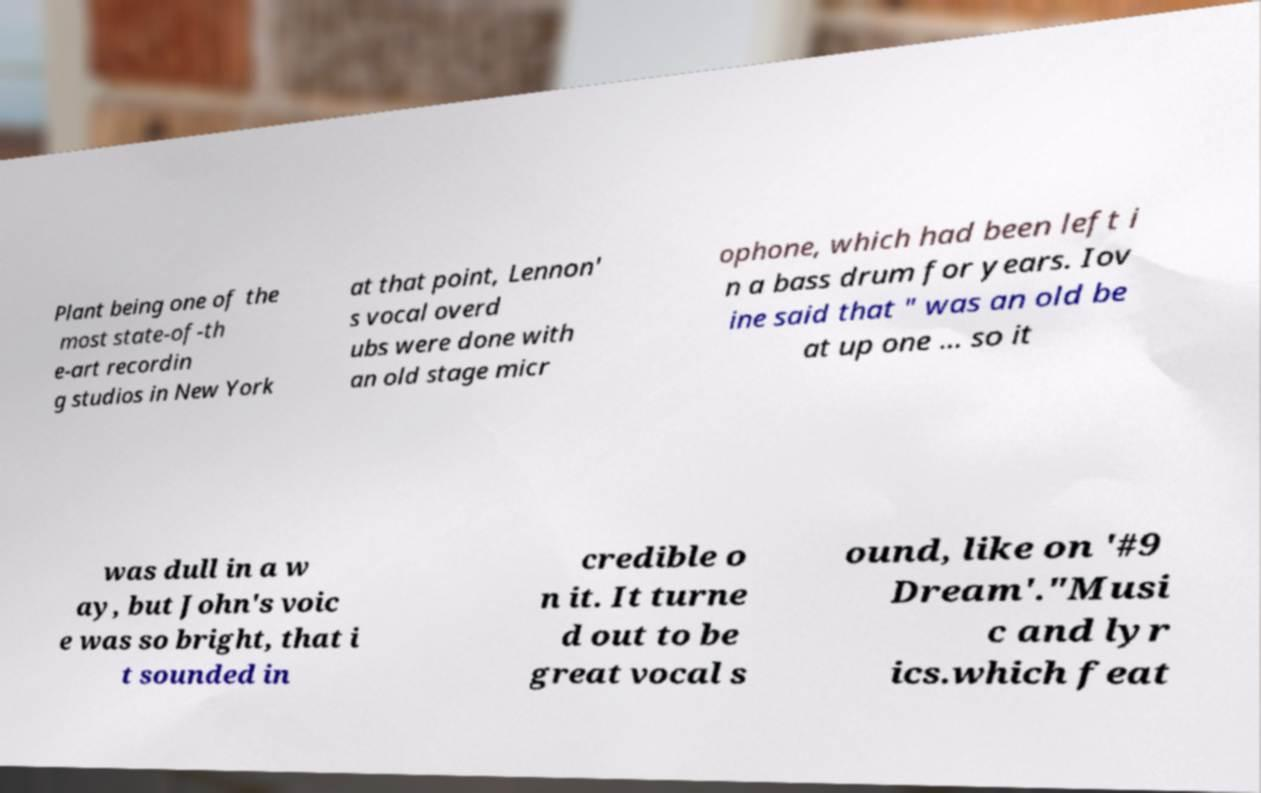Can you read and provide the text displayed in the image?This photo seems to have some interesting text. Can you extract and type it out for me? Plant being one of the most state-of-th e-art recordin g studios in New York at that point, Lennon' s vocal overd ubs were done with an old stage micr ophone, which had been left i n a bass drum for years. Iov ine said that " was an old be at up one ... so it was dull in a w ay, but John's voic e was so bright, that i t sounded in credible o n it. It turne d out to be great vocal s ound, like on '#9 Dream'."Musi c and lyr ics.which feat 